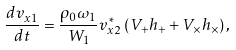<formula> <loc_0><loc_0><loc_500><loc_500>\frac { d v _ { x 1 } } { d t } = \frac { \rho _ { 0 } \omega _ { 1 } } { W _ { 1 } } v _ { x 2 } ^ { \ast } \left ( V _ { + } h _ { + } + V _ { \times } h _ { \times } \right ) ,</formula> 